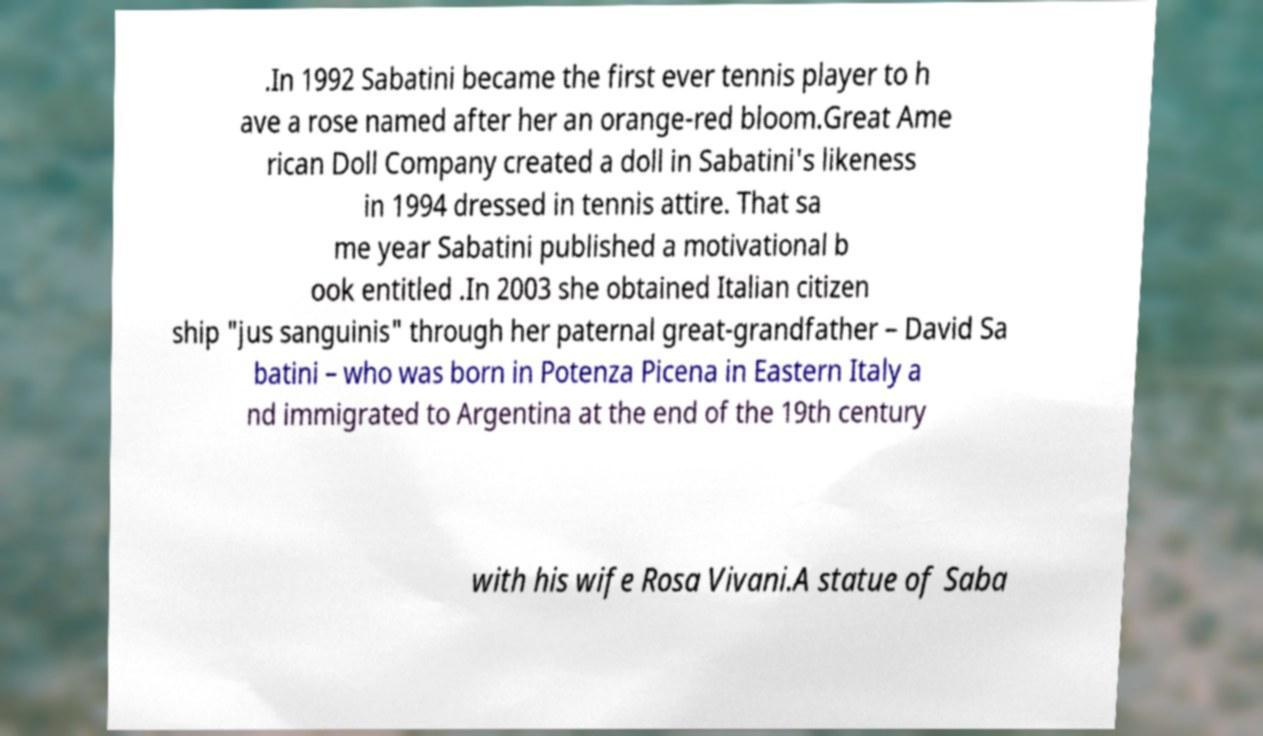For documentation purposes, I need the text within this image transcribed. Could you provide that? .In 1992 Sabatini became the first ever tennis player to h ave a rose named after her an orange-red bloom.Great Ame rican Doll Company created a doll in Sabatini's likeness in 1994 dressed in tennis attire. That sa me year Sabatini published a motivational b ook entitled .In 2003 she obtained Italian citizen ship "jus sanguinis" through her paternal great-grandfather – David Sa batini – who was born in Potenza Picena in Eastern Italy a nd immigrated to Argentina at the end of the 19th century with his wife Rosa Vivani.A statue of Saba 